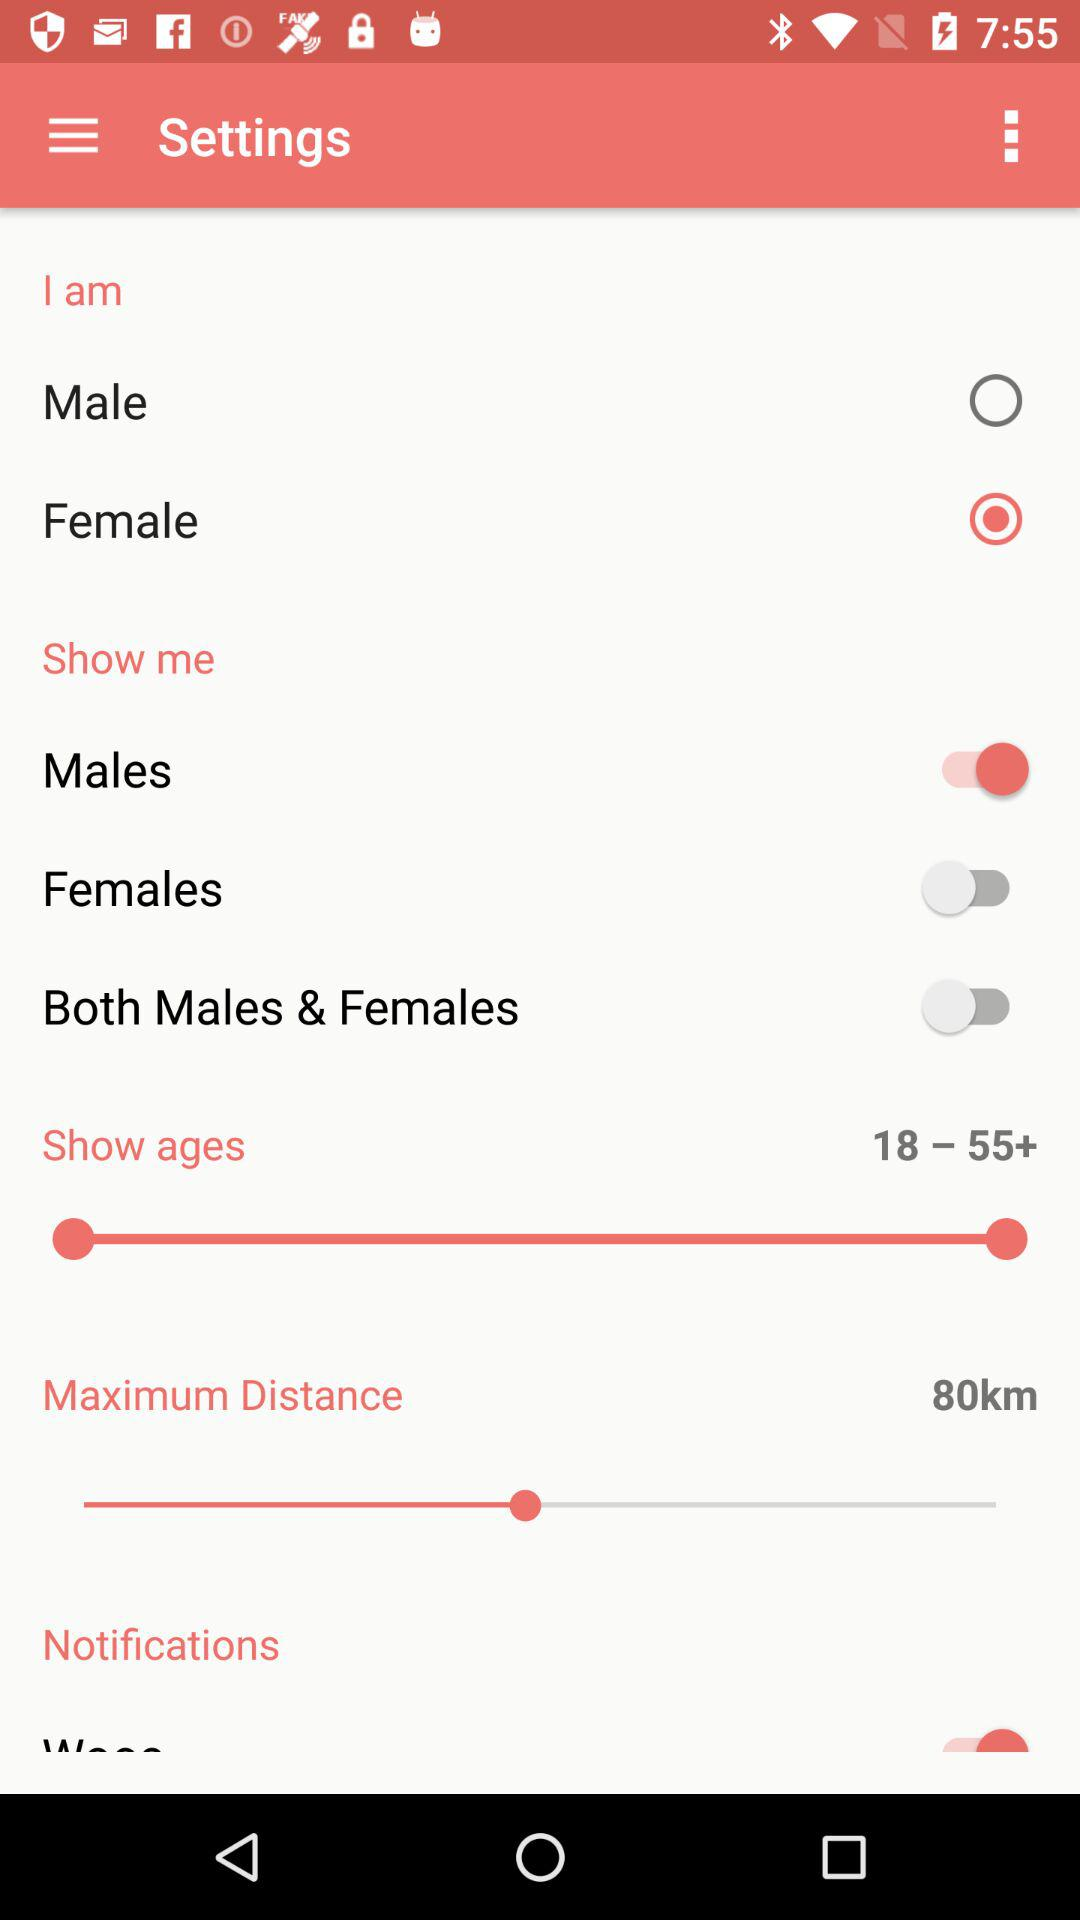What is the maximum distance? The maximum distance is 80 km. 